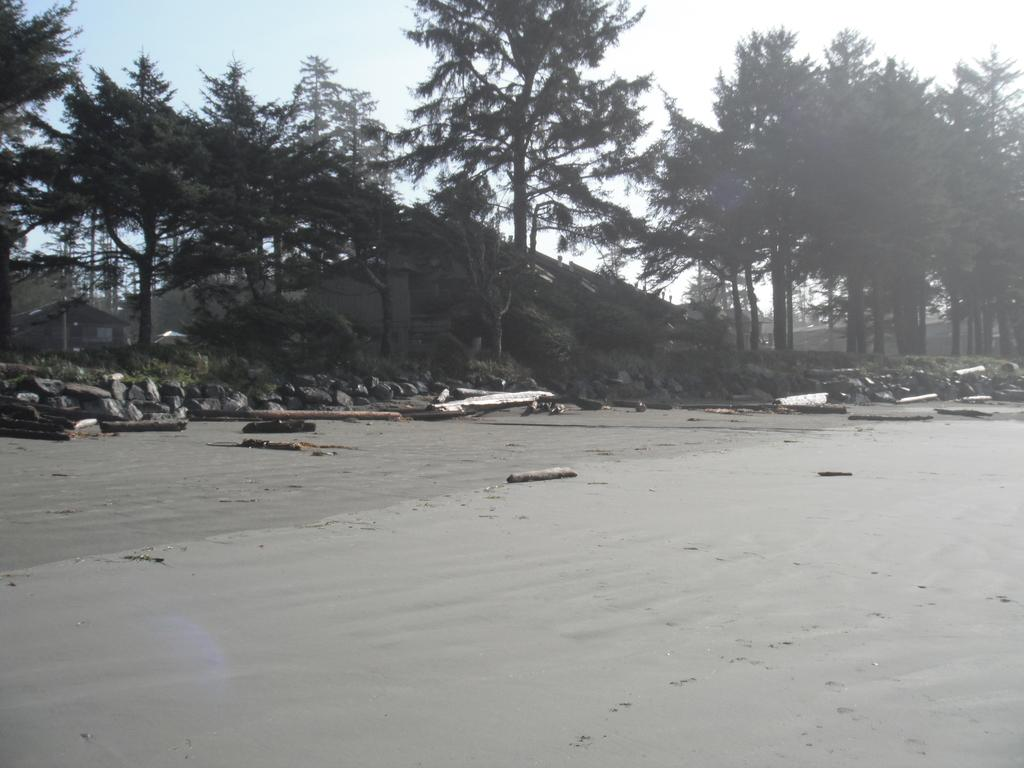What type of natural elements can be seen in the background of the image? There are trees and the sky visible in the background of the image. What type of man-made structures are present in the background of the image? There are houses in the background of the image. What type of objects can be found on the ground in the image? There are rocks and wooden branches in the image. What type of crown is being worn by the tree in the image? There is no crown present in the image, as it features trees, houses, rocks, and wooden branches. What type of stew is being prepared in the image? There is no stew present in the image; it does not depict any cooking or food preparation activities. 